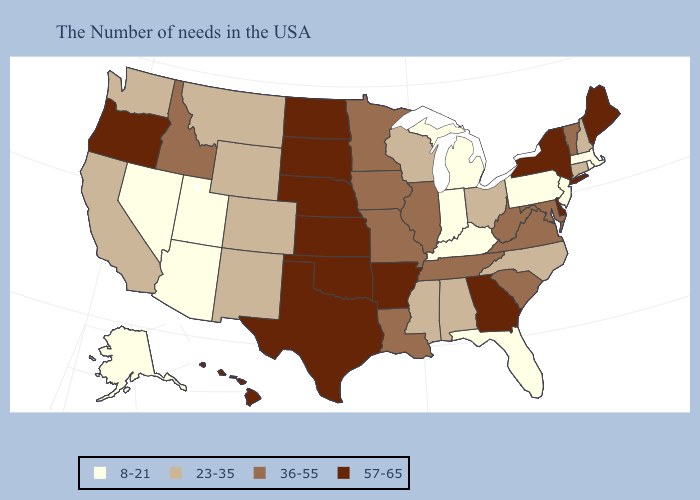Name the states that have a value in the range 23-35?
Give a very brief answer. New Hampshire, Connecticut, North Carolina, Ohio, Alabama, Wisconsin, Mississippi, Wyoming, Colorado, New Mexico, Montana, California, Washington. Name the states that have a value in the range 57-65?
Write a very short answer. Maine, New York, Delaware, Georgia, Arkansas, Kansas, Nebraska, Oklahoma, Texas, South Dakota, North Dakota, Oregon, Hawaii. Does Minnesota have the lowest value in the MidWest?
Quick response, please. No. Name the states that have a value in the range 57-65?
Write a very short answer. Maine, New York, Delaware, Georgia, Arkansas, Kansas, Nebraska, Oklahoma, Texas, South Dakota, North Dakota, Oregon, Hawaii. What is the value of New York?
Concise answer only. 57-65. What is the value of Utah?
Keep it brief. 8-21. What is the value of Georgia?
Short answer required. 57-65. Which states have the lowest value in the USA?
Be succinct. Massachusetts, Rhode Island, New Jersey, Pennsylvania, Florida, Michigan, Kentucky, Indiana, Utah, Arizona, Nevada, Alaska. Among the states that border Ohio , does Indiana have the highest value?
Concise answer only. No. Among the states that border Kentucky , which have the lowest value?
Write a very short answer. Indiana. What is the value of North Carolina?
Give a very brief answer. 23-35. What is the value of South Carolina?
Keep it brief. 36-55. Name the states that have a value in the range 23-35?
Keep it brief. New Hampshire, Connecticut, North Carolina, Ohio, Alabama, Wisconsin, Mississippi, Wyoming, Colorado, New Mexico, Montana, California, Washington. Does Wyoming have the lowest value in the USA?
Quick response, please. No. Name the states that have a value in the range 36-55?
Answer briefly. Vermont, Maryland, Virginia, South Carolina, West Virginia, Tennessee, Illinois, Louisiana, Missouri, Minnesota, Iowa, Idaho. 